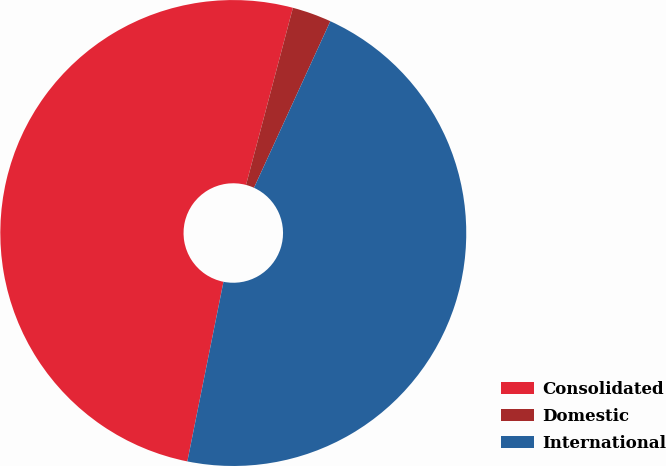Convert chart to OTSL. <chart><loc_0><loc_0><loc_500><loc_500><pie_chart><fcel>Consolidated<fcel>Domestic<fcel>International<nl><fcel>50.96%<fcel>2.72%<fcel>46.32%<nl></chart> 